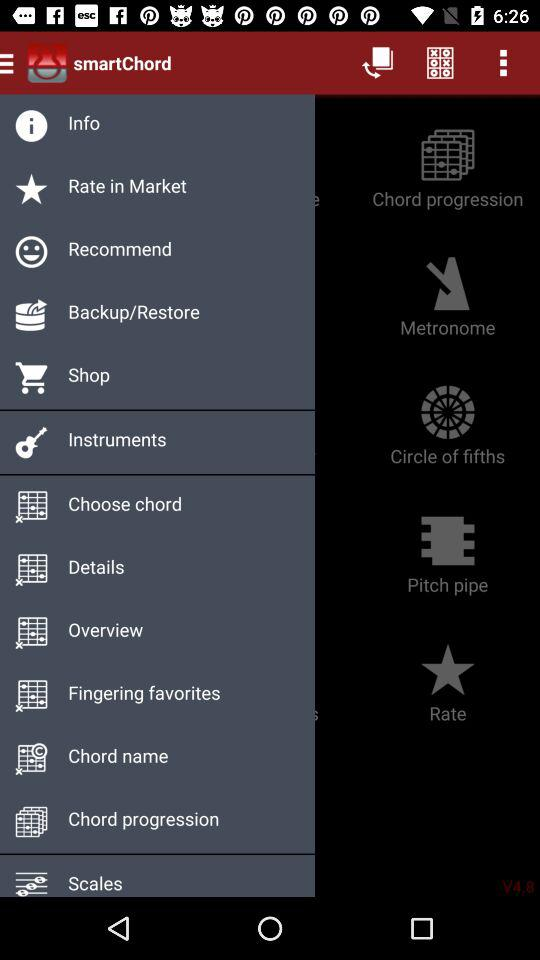What is the name of the application? The name of the application is "smartChord". 